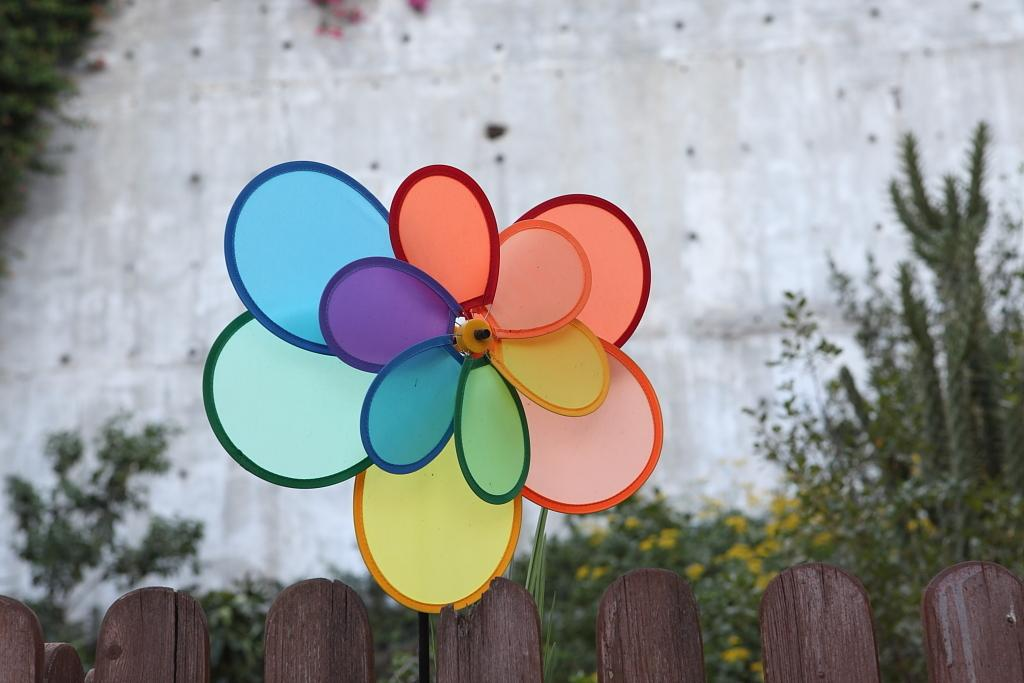What is the main object in the image? There is a decorative windmill in the image. Where is the windmill located? The windmill is on a wooden fencing. What can be seen in the background of the image? There are plants in the background of the image. What type of structure is visible in the image? There is a wall in the image. What type of prose is being recited by the turkey in the image? There is no turkey present in the image, and therefore no prose being recited. Can you see a pear hanging from the windmill in the image? There is no pear present in the image, and it is not hanging from the windmill. 